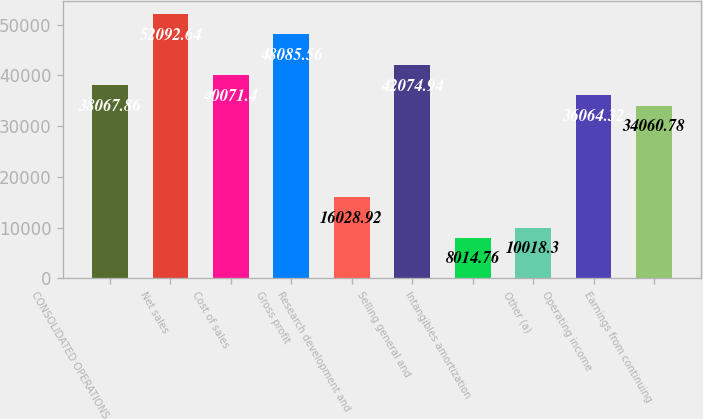<chart> <loc_0><loc_0><loc_500><loc_500><bar_chart><fcel>CONSOLIDATED OPERATIONS<fcel>Net sales<fcel>Cost of sales<fcel>Gross profit<fcel>Research development and<fcel>Selling general and<fcel>Intangibles amortization<fcel>Other (a)<fcel>Operating income<fcel>Earnings from continuing<nl><fcel>38067.9<fcel>52092.6<fcel>40071.4<fcel>48085.6<fcel>16028.9<fcel>42074.9<fcel>8014.76<fcel>10018.3<fcel>36064.3<fcel>34060.8<nl></chart> 